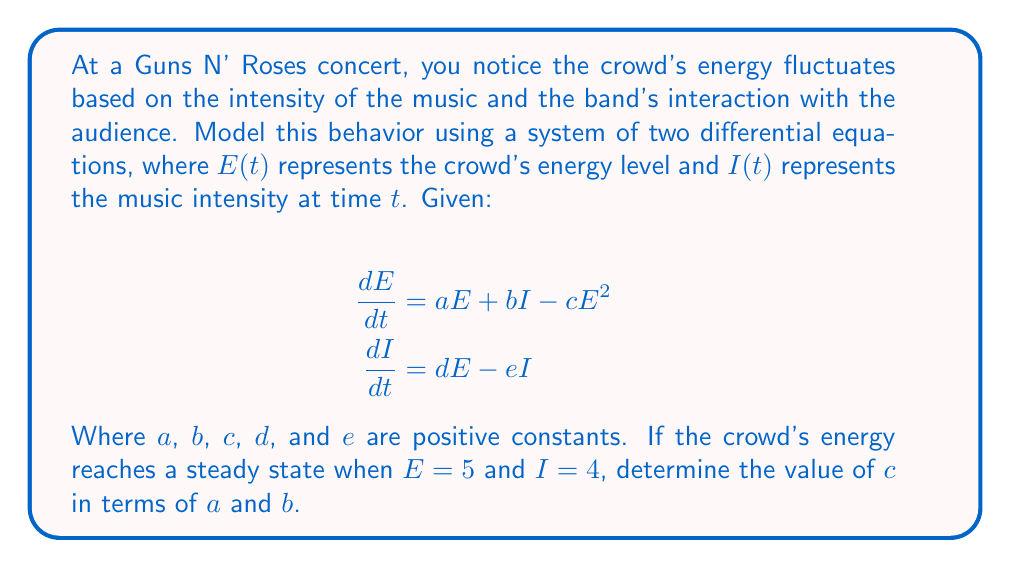Can you solve this math problem? Let's approach this step-by-step:

1) At steady state, the derivatives are zero. So we can set both equations to zero:

   $$\frac{dE}{dt} = aE + bI - cE^2 = 0$$
   $$\frac{dI}{dt} = dE - eI = 0$$

2) We're given that at steady state, $E = 5$ and $I = 4$. Let's substitute these values into the second equation:

   $$0 = d(5) - e(4)$$
   $$0 = 5d - 4e$$
   $$5d = 4e$$

   This relates $d$ and $e$, but we don't need to solve for them explicitly.

3) Now, let's focus on the first equation. Substituting $E = 5$ and $I = 4$:

   $$0 = a(5) + b(4) - c(5^2)$$

4) Simplify:

   $$0 = 5a + 4b - 25c$$

5) Rearrange to solve for $c$:

   $$25c = 5a + 4b$$
   $$c = \frac{5a + 4b}{25}$$

6) Simplify:

   $$c = \frac{a}{5} + \frac{4b}{25}$$

This expresses $c$ in terms of $a$ and $b$ as required.
Answer: $c = \frac{a}{5} + \frac{4b}{25}$ 